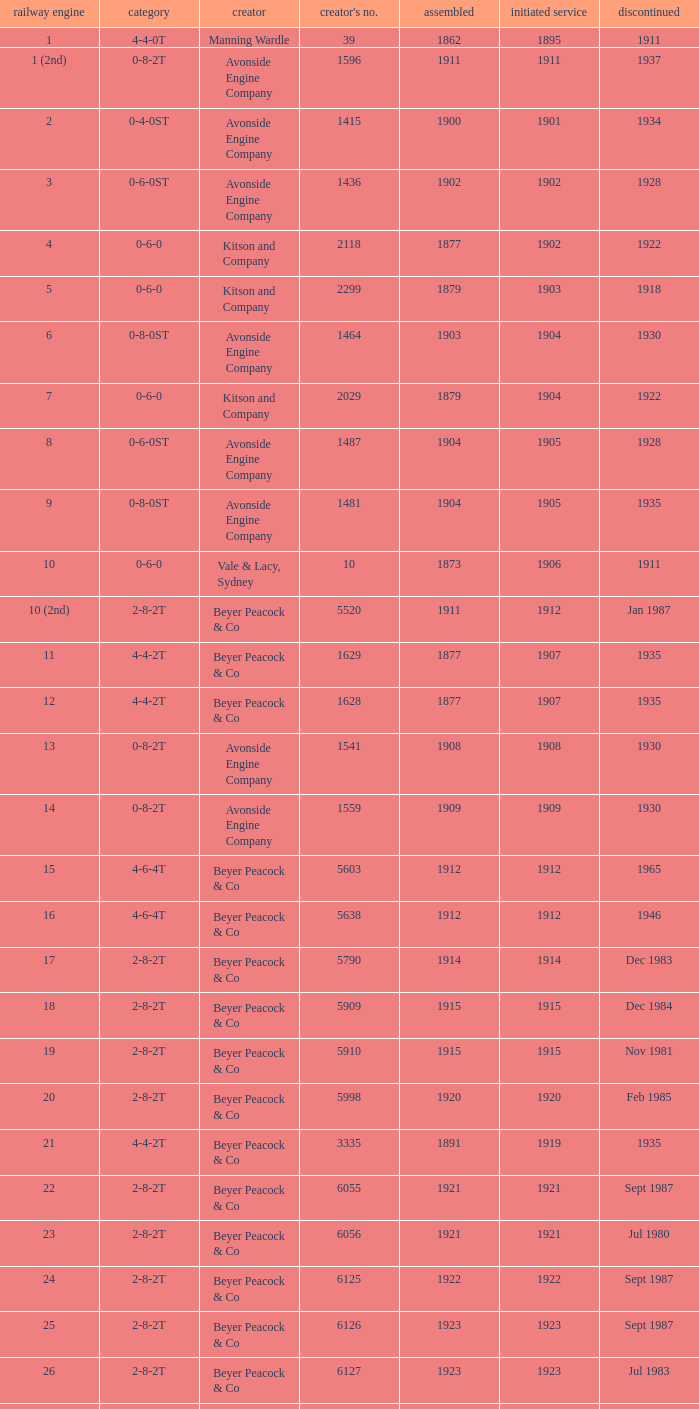Which locomotive had a 2-8-2t type, entered service year prior to 1915, and which was built after 1911? 17.0. 